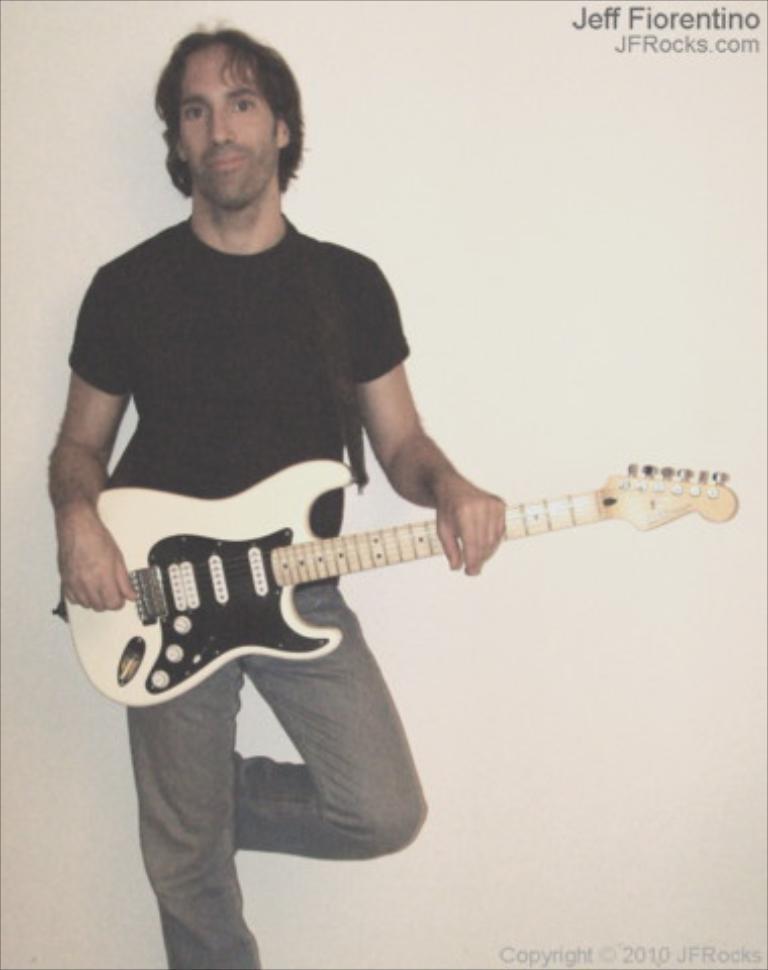How would you summarize this image in a sentence or two? In the image we can see one man standing and holding guitar. In the background there is a wall. 